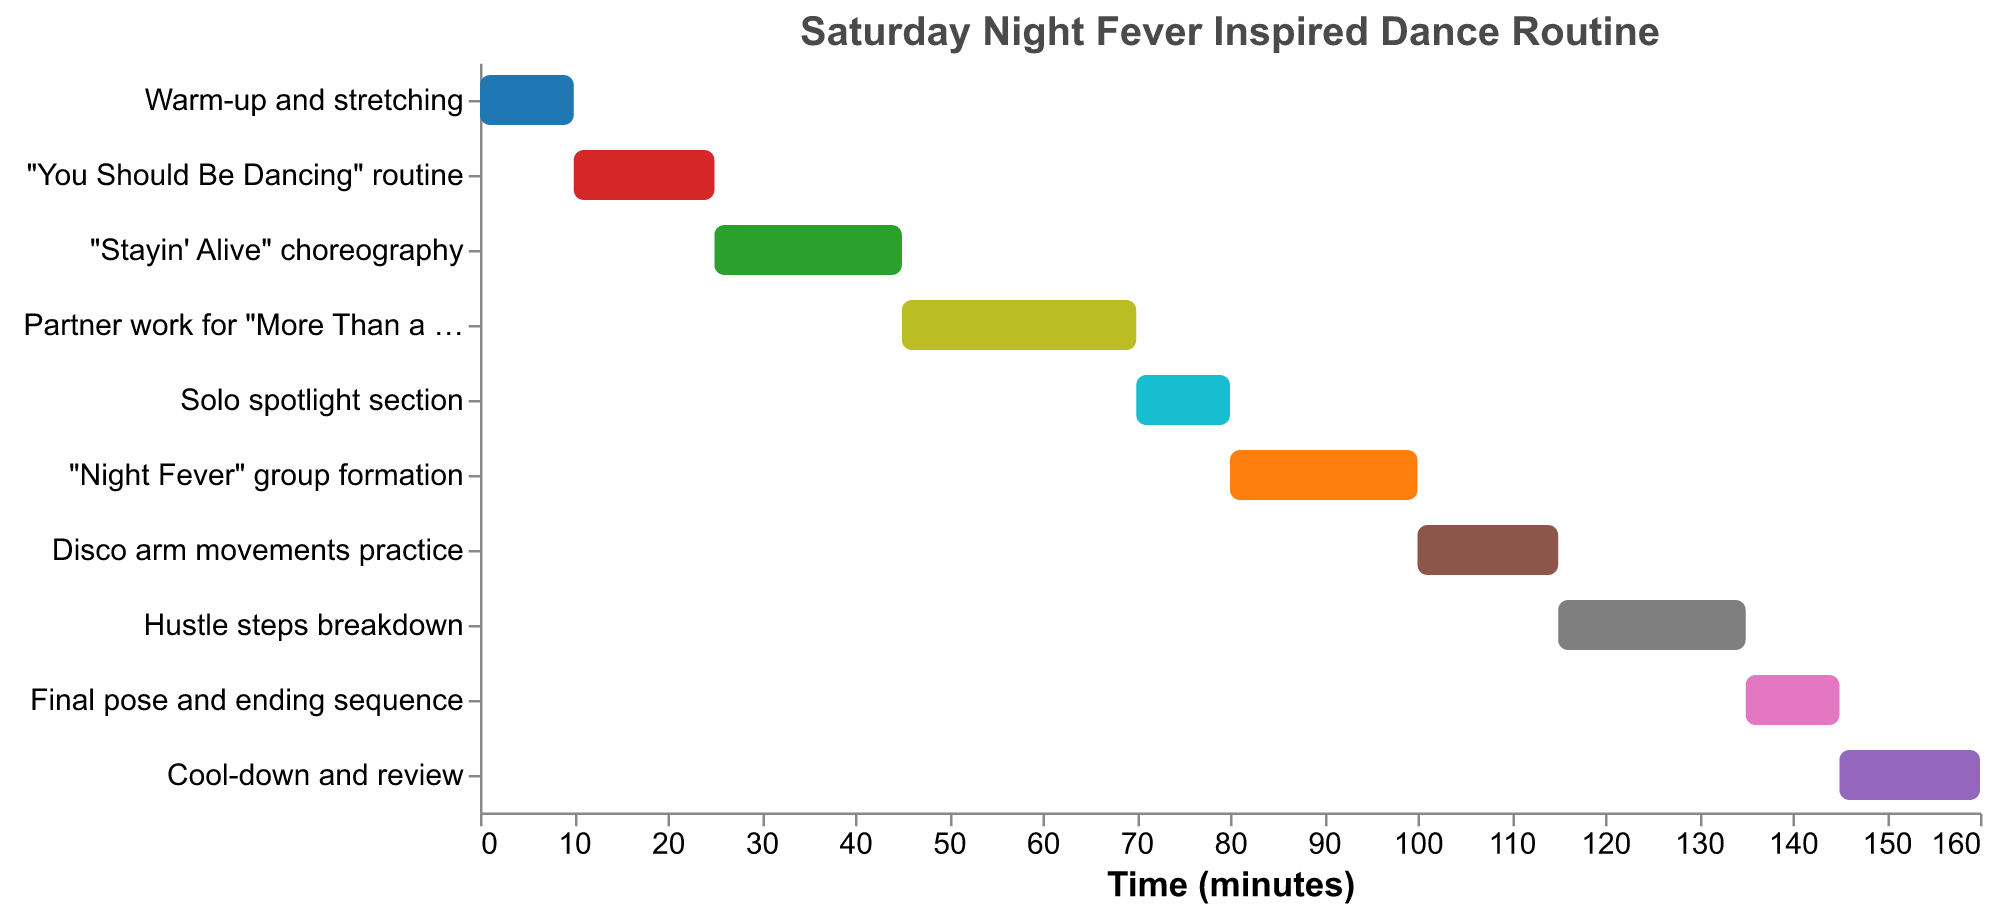What is the duration of the "Hustle steps breakdown" section? The "Hustle steps breakdown" section starts at 115 minutes and lasts for 20 minutes.
Answer: 20 minutes Which section of the routine follows the "Partner work for 'More Than a Woman'"? The "Solo spotlight section" follows directly after the "Partner work for 'More Than a Woman'" section.
Answer: Solo spotlight section What is the total duration of all dance routine sections combined, excluding the warm-up and cool-down periods? Excluding the warm-up (10 mins) and cool-down (15 mins), the durations are: 15 (You Should Be Dancing) + 20 (Stayin' Alive) + 25 (More Than a Woman) + 10 (Solo spotlight) + 20 (Night Fever) + 15 (Disco arm movements) + 20 (Hustle steps) + 10 (Final pose) = 135 mins.
Answer: 135 minutes Which section has the shortest duration and how long is it? The "Solo spotlight section" and "Final pose and ending sequence" both have the shortest duration, each lasting 10 minutes.
Answer: Solo spotlight section and Final pose and ending sequence, 10 minutes How much time passes between the end of the "Stayin' Alive choreography" and the start of the "Disco arm movements practice"? "Stayin' Alive choreography" ends at 45 minutes and "Disco arm movements practice" starts at 100 minutes. The time gap is 100 - 45 = 55 minutes.
Answer: 55 minutes When does the "Night Fever group formation" section end? The "Night Fever group formation" starts at 80 minutes and lasts for 20 minutes, so it ends at 100 minutes (80 + 20).
Answer: 100 minutes What is the difference in duration between the "Partner work for 'More Than a Woman'" and the "You Should Be Dancing" routines? The duration for "Partner work" is 25 minutes, and for "You Should Be Dancing," it is 15 minutes. The difference is 25 - 15 = 10 minutes.
Answer: 10 minutes Which tasks have a duration of 20 minutes? The tasks with a duration of 20 minutes are "Stayin' Alive choreography," "Night Fever group formation," and "Hustle steps breakdown."
Answer: Stayin' Alive choreography, Night Fever group formation, and Hustle steps breakdown 